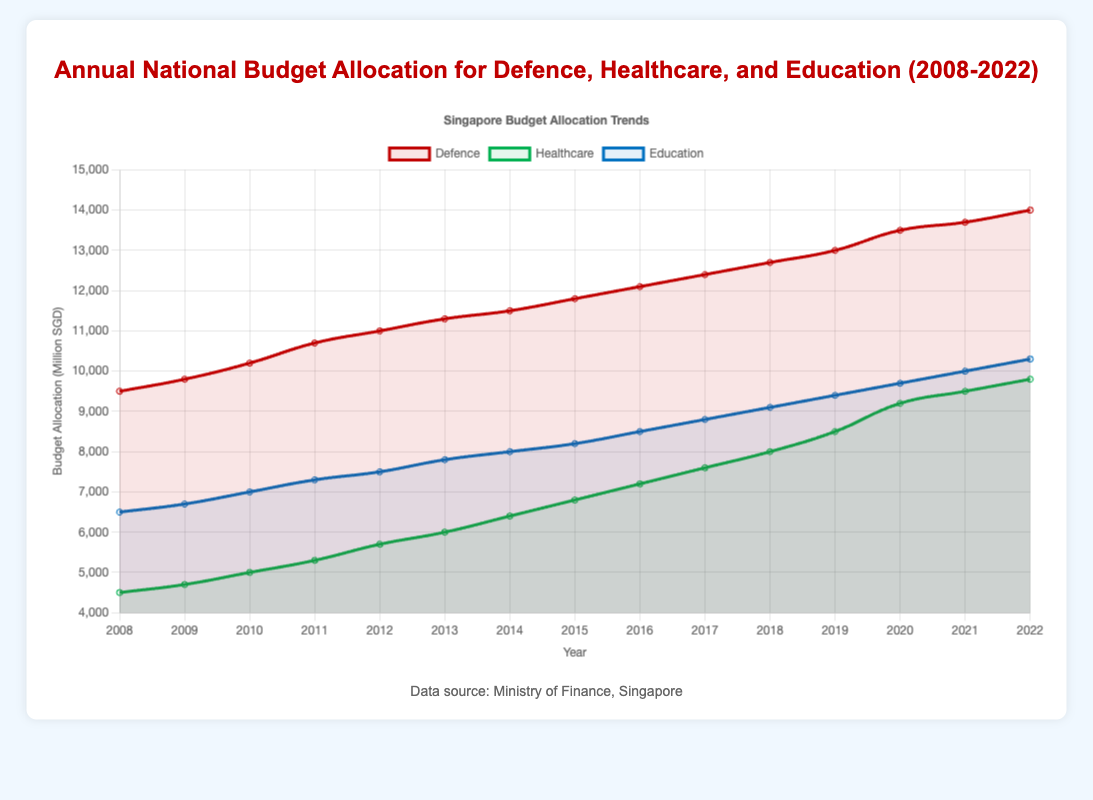What's the average annual budget allocation for defence over the 15 years? To find the average, sum all the defence budget values and divide by the number of years. The sum is 9500 + 9800 + 10200 + 10700 + 11000 + 11300 + 11500 + 11800 + 12100 + 12400 + 12700 + 13000 + 13500 + 13700 + 14000 = 188500. Divide by 15.
Answer: 12566.67 In which year did healthcare see the largest increase in budget allocation from the previous year? Identify the largest year-to-year increase by comparing the differences. The increase is greatest between 2019 (8500) and 2020 (9200), which is 700.
Answer: 2020 Comparing the budget allocations in 2015, which sector received the least funding? Refer to the 2015 data points. For 2015: defence = 11800, healthcare = 6800, education = 8200. The smallest value is healthcare.
Answer: Healthcare In 2021, how much more was allocated to education than to healthcare? In 2021, education received 10000 and healthcare received 9500. Subtract healthcare from education: 10000 - 9500 = 500.
Answer: 500 What is the trend of budget allocation for defence from 2008 to 2022? Look at the defence line on the graph for the entire period. The values consistently increase every year. This shows a steady upward trend.
Answer: Increasing Between 2010 and 2015, which year had the highest budget allocation for education? Refer to the numbers for education from 2010 to 2015: 7000, 7300, 7500, 7800, 8000, 8200. The maximum value, 8200, occurs in 2015.
Answer: 2015 What color represents the defence budget in the plot? Identify the line or section in the plot associated with the defence budget visually. It is represented by a red line.
Answer: Red Compare the total budget allocations for healthcare and education in 2020. Which received more, and by how much? In 2020, healthcare received 9200 and education 9700. Education received more. 9700 - 9200 = 500.
Answer: Education by 500 Which sector had the smallest budget allocation increase from 2011 to 2012? Compare the increase for each sector: defence (11000-10700=300), healthcare (5700-5300=400), and education (7500-7300=200). The smallest increase is in education.
Answer: Education In which year did the education budget first exceed 9000? Check the education budgets year by year: it first exceeds 9000 in 2018 with 9100.
Answer: 2018 